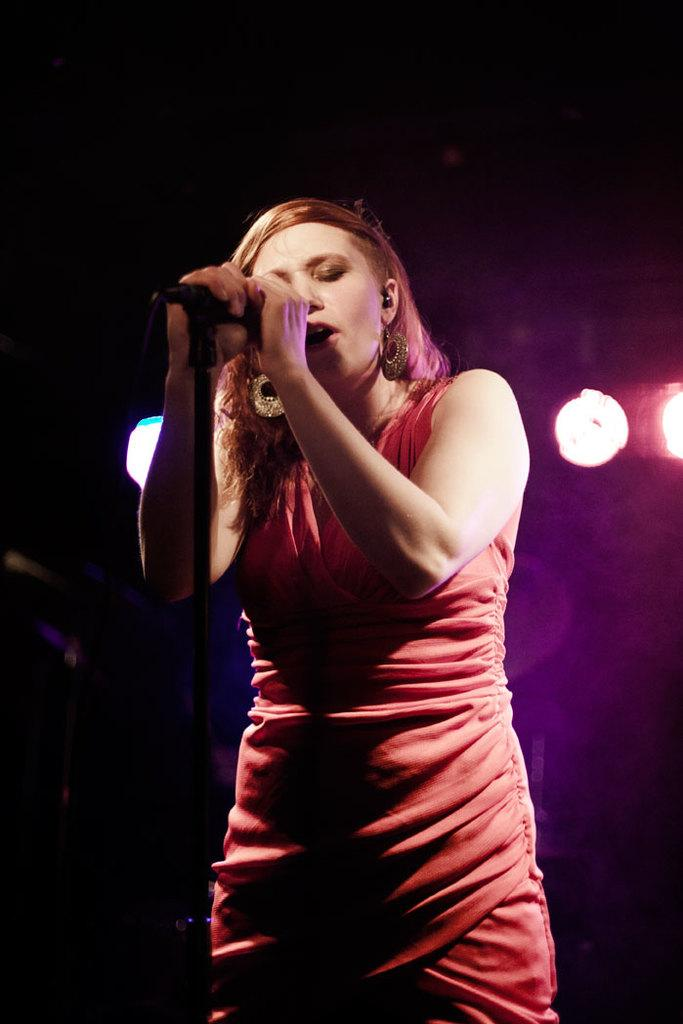Who is the main subject in the image? There is a woman in the image. What is the woman doing in the image? The woman is standing and singing. What is the woman holding in the image? The woman is holding a microphone. What can be seen in the background of the image? The background of the image is dark, and there are lights visible. What type of patch is sewn onto the woman's shirt in the image? There is no patch visible on the woman's shirt in the image. What function does the calculator serve in the image? There is no calculator present in the image. 